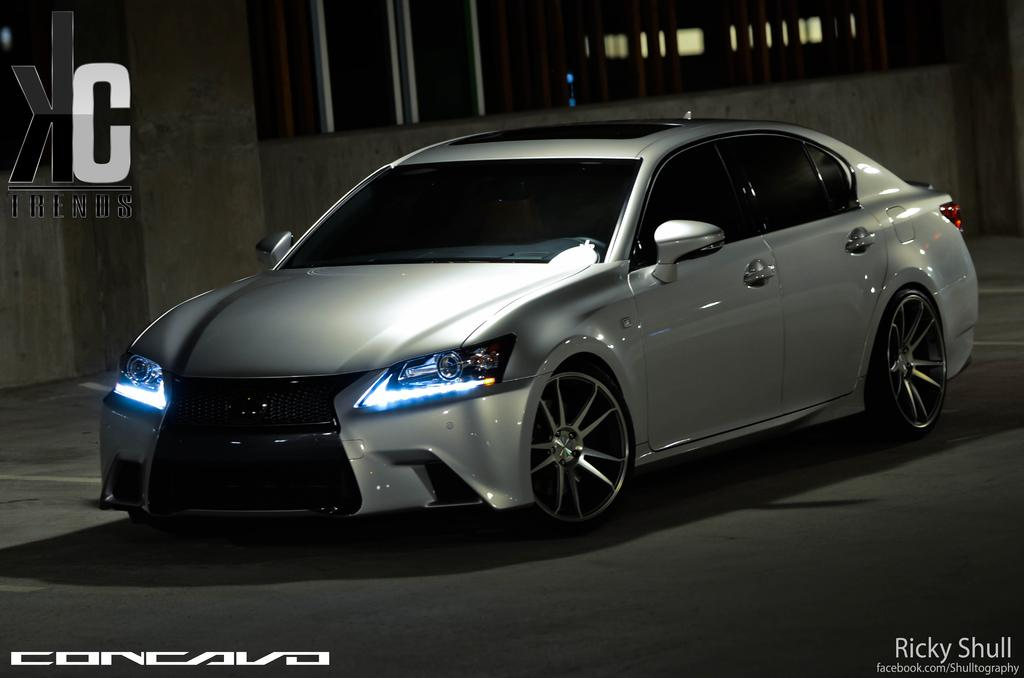What color is the car that is visible in the image? There is a white color car in the image. What else can be seen in the image besides the car? There are buildings in the image. How does the car generate heat in the image? The car does not generate heat in the image; there is no indication of any heat-related activity. 